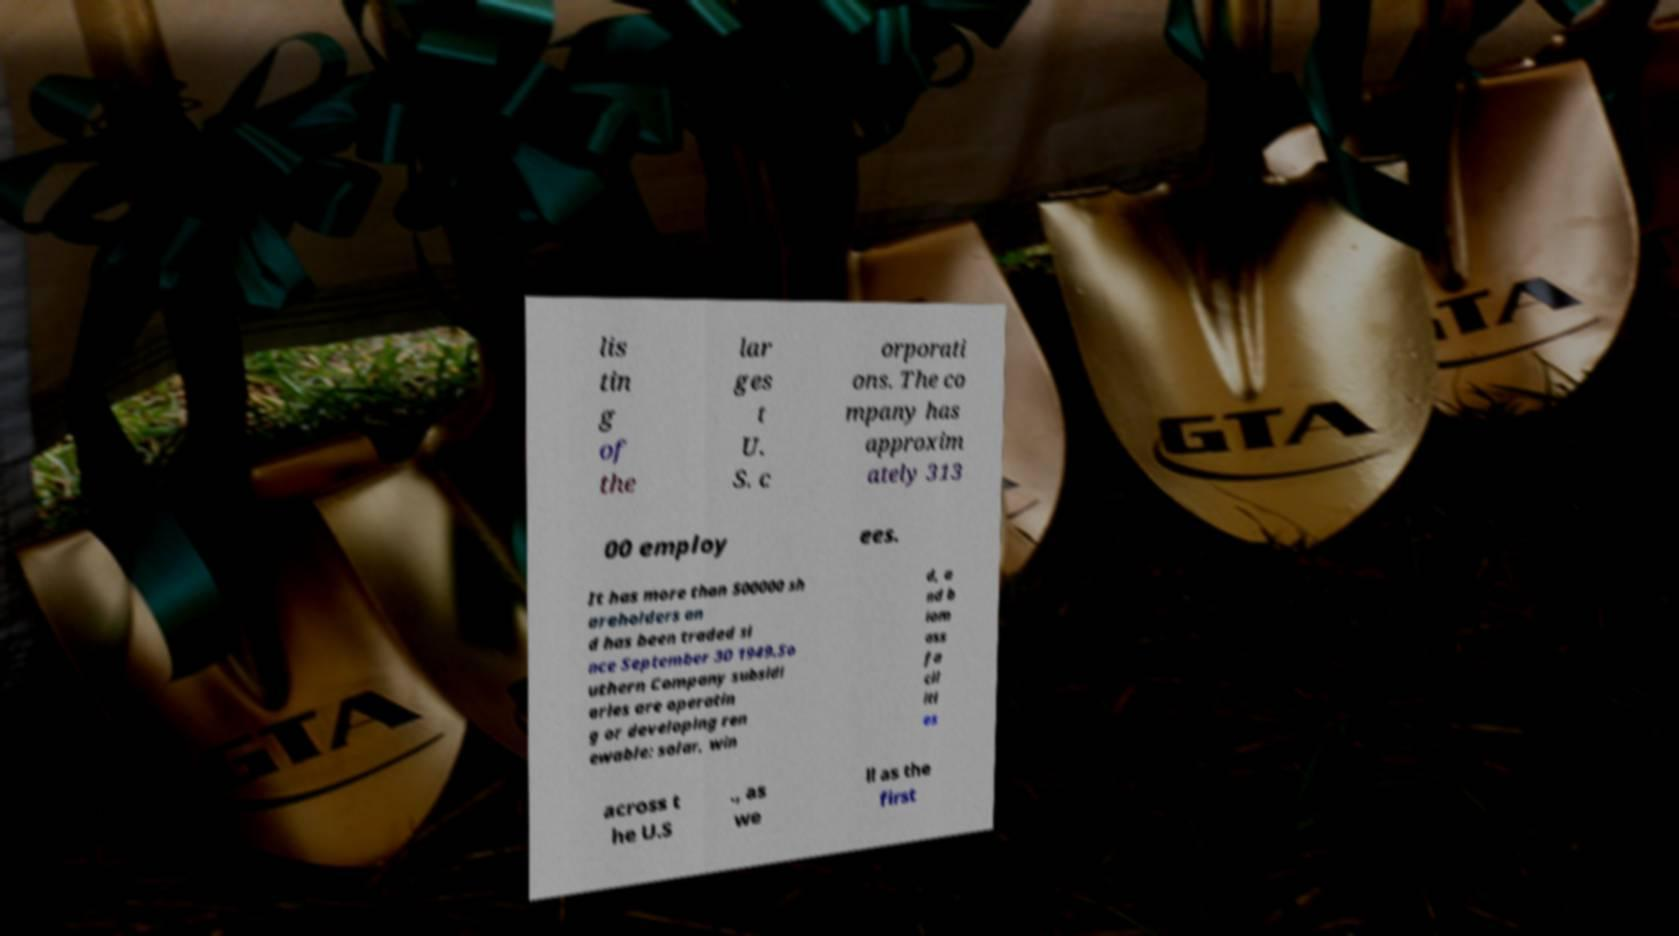Could you extract and type out the text from this image? lis tin g of the lar ges t U. S. c orporati ons. The co mpany has approxim ately 313 00 employ ees. It has more than 500000 sh areholders an d has been traded si nce September 30 1949.So uthern Company subsidi aries are operatin g or developing ren ewable: solar, win d, a nd b iom ass fa cil iti es across t he U.S ., as we ll as the first 